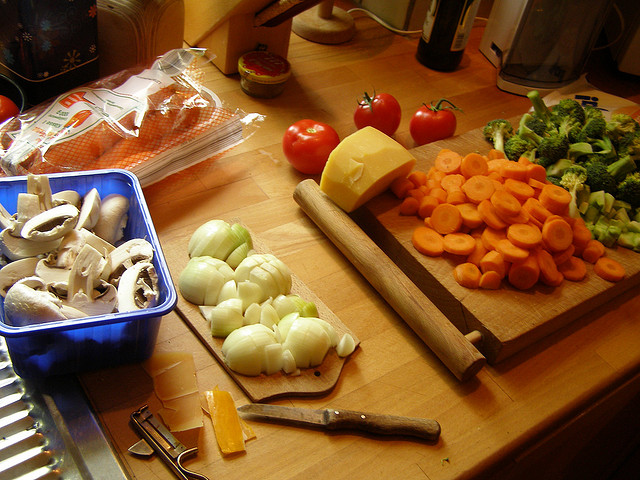How many bowls can be seen? Based on a careful examination of the image, there appear to be no bowls visible. The setting is a kitchen preparation area with various vegetables and a block of cheese laid out, but no bowls are in sight. 